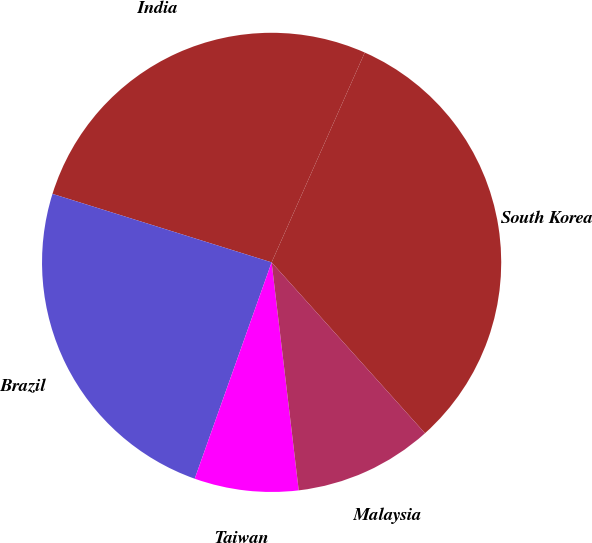Convert chart to OTSL. <chart><loc_0><loc_0><loc_500><loc_500><pie_chart><fcel>South Korea<fcel>India<fcel>Brazil<fcel>Taiwan<fcel>Malaysia<nl><fcel>31.71%<fcel>26.83%<fcel>24.39%<fcel>7.32%<fcel>9.76%<nl></chart> 